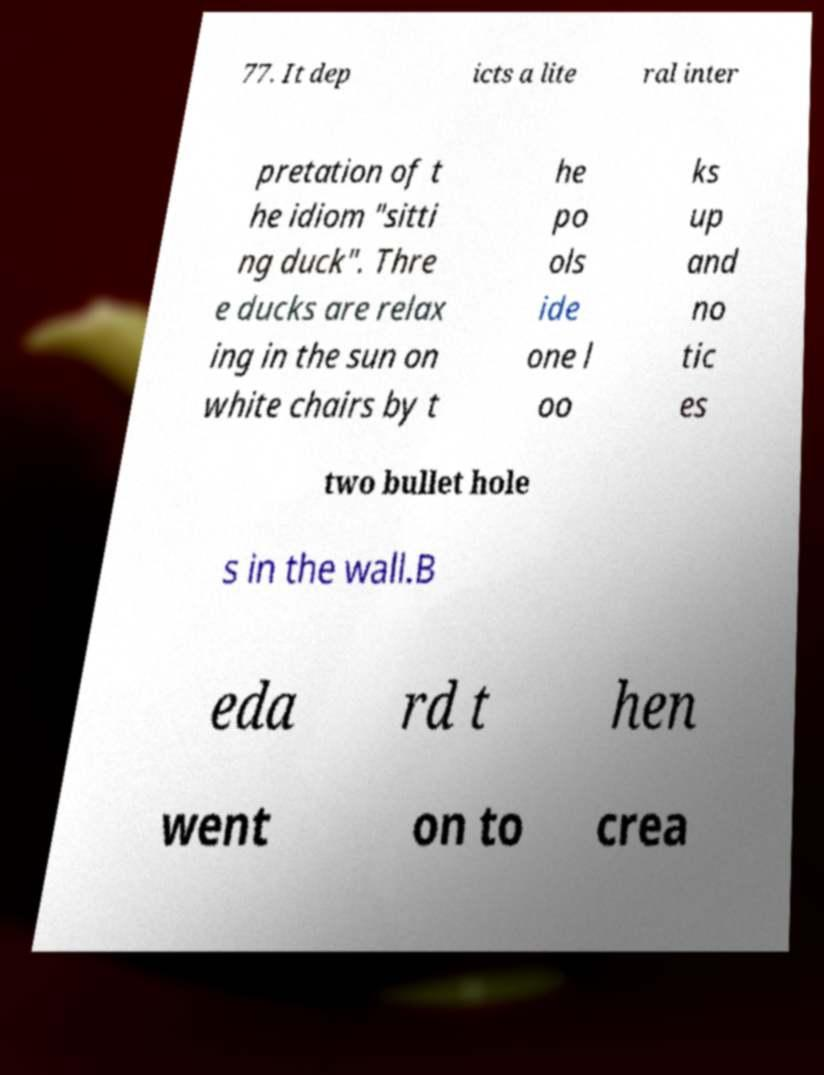Please identify and transcribe the text found in this image. 77. It dep icts a lite ral inter pretation of t he idiom "sitti ng duck". Thre e ducks are relax ing in the sun on white chairs by t he po ols ide one l oo ks up and no tic es two bullet hole s in the wall.B eda rd t hen went on to crea 